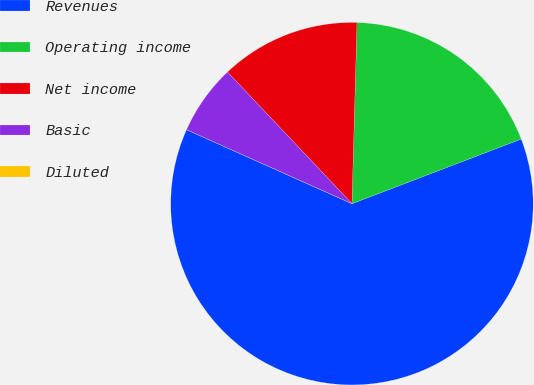<chart> <loc_0><loc_0><loc_500><loc_500><pie_chart><fcel>Revenues<fcel>Operating income<fcel>Net income<fcel>Basic<fcel>Diluted<nl><fcel>62.5%<fcel>18.75%<fcel>12.5%<fcel>6.25%<fcel>0.0%<nl></chart> 